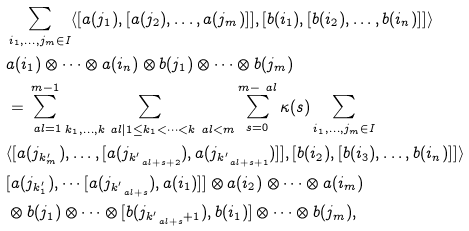<formula> <loc_0><loc_0><loc_500><loc_500>& \sum _ { i _ { 1 } , \dots , j _ { m } \in I } \langle [ a ( j _ { 1 } ) , [ a ( j _ { 2 } ) , \dots , a ( j _ { m } ) ] ] , [ b ( i _ { 1 } ) , [ b ( i _ { 2 } ) , \dots , b ( i _ { n } ) ] ] \rangle \\ & a ( i _ { 1 } ) \otimes \cdots \otimes a ( i _ { n } ) \otimes b ( j _ { 1 } ) \otimes \cdots \otimes b ( j _ { m } ) \\ & = \sum _ { \ a l = 1 } ^ { m - 1 } \sum _ { k _ { 1 } , \dots , k _ { \ } a l | 1 \leq k _ { 1 } < \cdots < k _ { \ } a l < m } \sum _ { s = 0 } ^ { m - \ a l } \kappa ( s ) \sum _ { i _ { 1 } , \dots , j _ { m } \in I } \\ & \langle [ a ( j _ { k ^ { \prime } _ { m } } ) , \dots , [ a ( j _ { k ^ { \prime } _ { \ a l + s + 2 } } ) , a ( j _ { k ^ { \prime } _ { \ a l + s + 1 } } ) ] ] , [ b ( i _ { 2 } ) , [ b ( i _ { 3 } ) , \dots , b ( i _ { n } ) ] ] \rangle \\ & [ a ( j _ { k ^ { \prime } _ { 1 } } ) , \cdots [ a ( j _ { k ^ { \prime } _ { \ a l + s } } ) , a ( i _ { 1 } ) ] ] \otimes a ( i _ { 2 } ) \otimes \cdots \otimes a ( i _ { m } ) \\ & \otimes b ( j _ { 1 } ) \otimes \cdots \otimes [ b ( j _ { k ^ { \prime } _ { \ a l + s } + 1 } ) , b ( i _ { 1 } ) ] \otimes \cdots \otimes b ( j _ { m } ) ,</formula> 